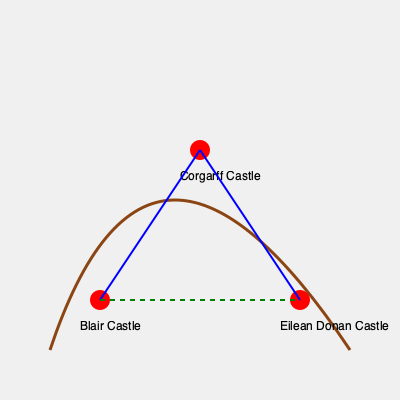On this topographical map of Scotland, three Jacobite strongholds are marked: Blair Castle, Corgarff Castle, and Eilean Donan Castle. Considering the mountainous terrain represented by the brown curve, which route would be the shortest and most strategic for Jacobite forces to travel between all three castles? To determine the shortest and most strategic route between the three Jacobite strongholds, we need to consider both distance and terrain:

1. The map shows a mountainous region (represented by the brown curve) between the castles.

2. There are two possible routes:
   a) Blair Castle → Corgarff Castle → Eilean Donan Castle (blue lines)
   b) Blair Castle → Eilean Donan Castle → Corgarff Castle (green dashed line + part of blue line)

3. Route (a) follows the contours of the mountainous region, which would likely be easier to traverse despite being longer in total distance.

4. Route (b) appears shorter in straight-line distance but crosses directly over the mountainous region, which would be more difficult and time-consuming to navigate.

5. Historically, Jacobite forces often used their knowledge of Highland geography to their advantage, preferring routes that followed glens and avoided exposed high ground.

6. The blue route (a) allows for better concealment and potentially quicker movement, despite being longer in total distance.

Therefore, the shortest and most strategic route would be Blair Castle → Corgarff Castle → Eilean Donan Castle, following the blue lines on the map.
Answer: Blair Castle → Corgarff Castle → Eilean Donan Castle 